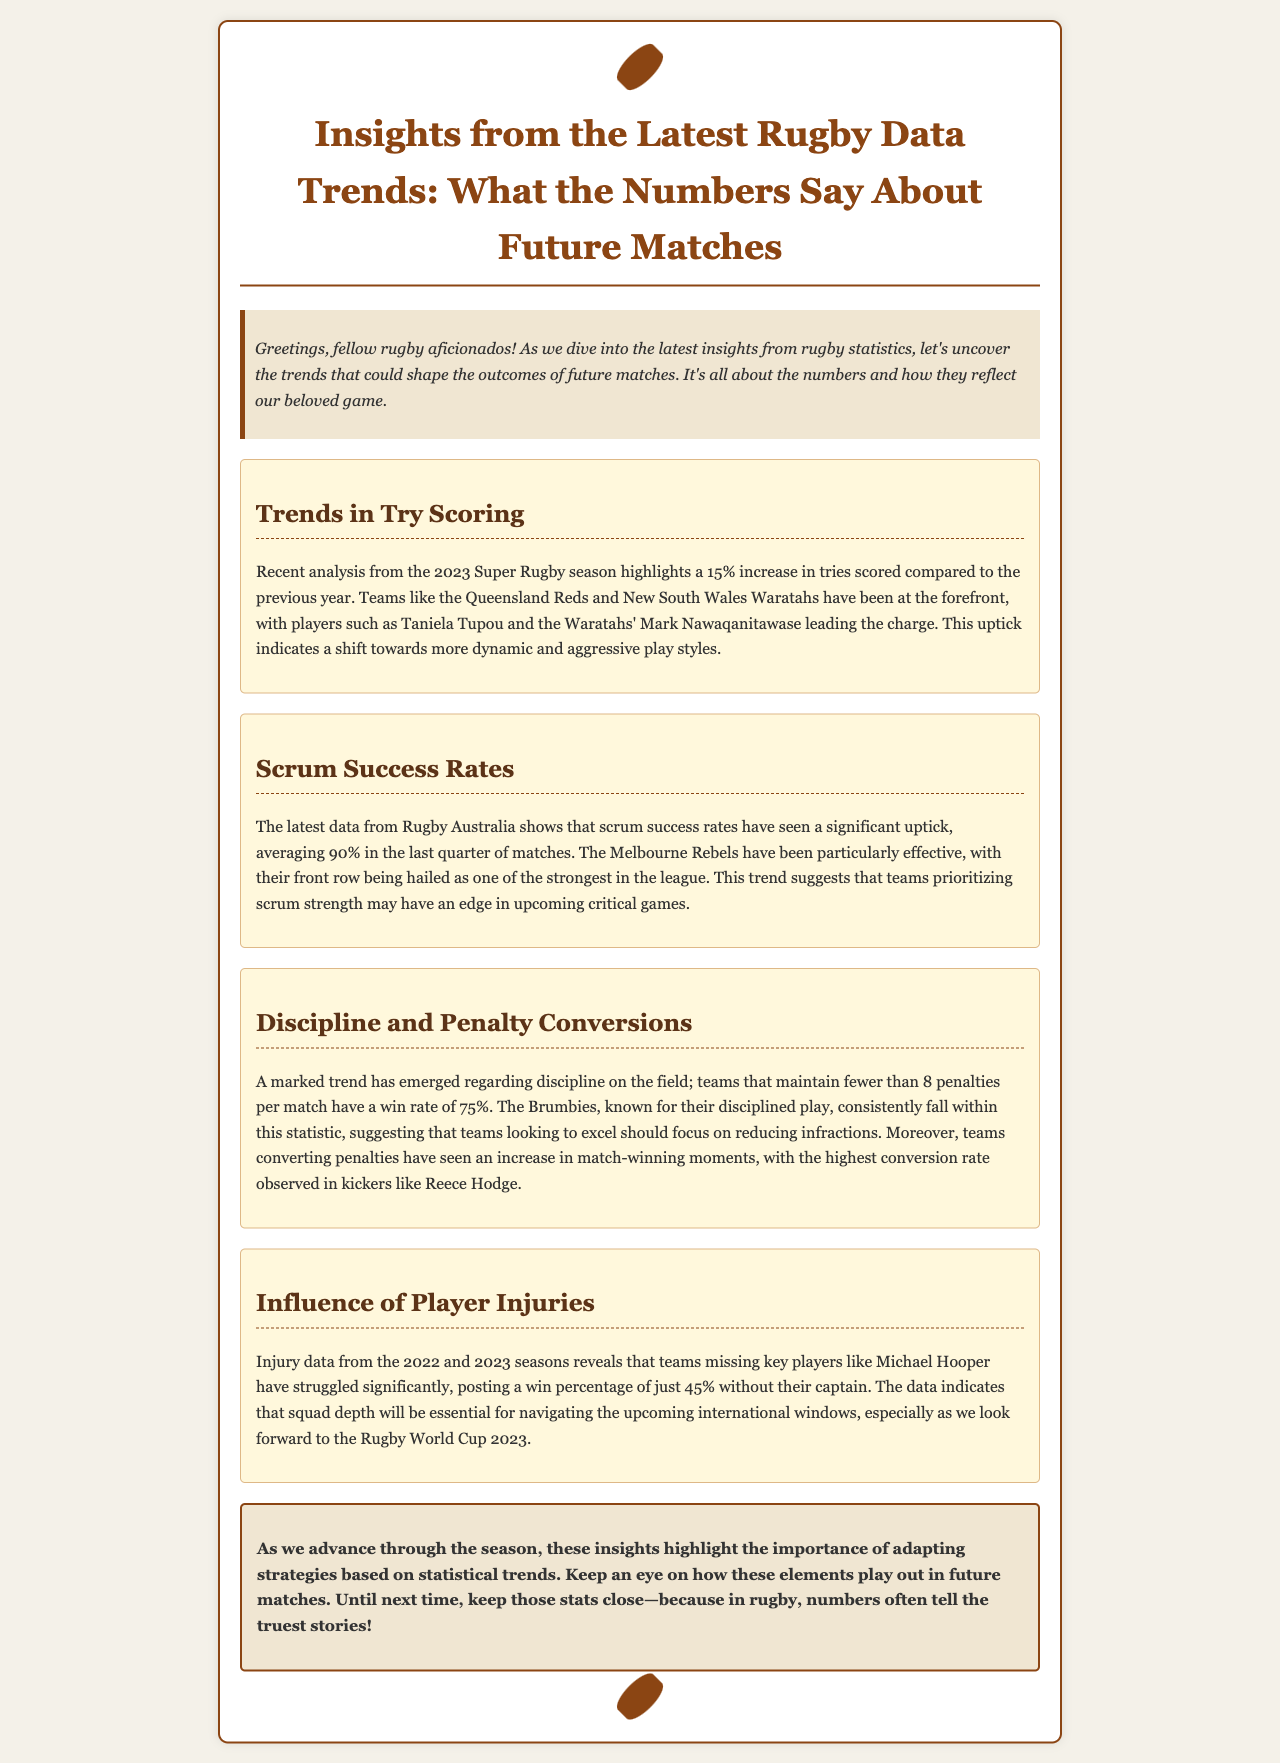What percentage increase in tries was recorded in the 2023 Super Rugby season? The document states that there was a 15% increase in tries scored compared to the previous year.
Answer: 15% Which team has the highest average scrum success rate in the last quarter of matches? The document mentions that the Melbourne Rebels have been particularly effective, indicating they likely have the highest scrum success rate.
Answer: Melbourne Rebels What is the win rate of teams maintaining fewer than 8 penalties per match? The text indicates that these teams have a win rate of 75%.
Answer: 75% Who is the player mentioned that struggles without their captain, Michael Hooper? The document refers specifically to the team that struggles significantly without their captain, indicating that the focus is on the teams themselves rather than individuals beyond Hooper.
Answer: Teams What element should teams focus on to excel according to the newsletter? The document suggests that teams looking to excel should focus on reducing infractions.
Answer: Reducing infractions Which player's kicking has the highest conversion rate observed? The information in the document highlights Reece Hodge as the kicker with the highest conversion rate.
Answer: Reece Hodge What is the focus of the newsletter for rugby fans? The newsletter aims to uncover trends shaping future match outcomes through statistics.
Answer: Trends What is the essential aspect for navigating upcoming international windows? The document emphasizes that squad depth will be essential in navigating upcoming international windows.
Answer: Squad depth 